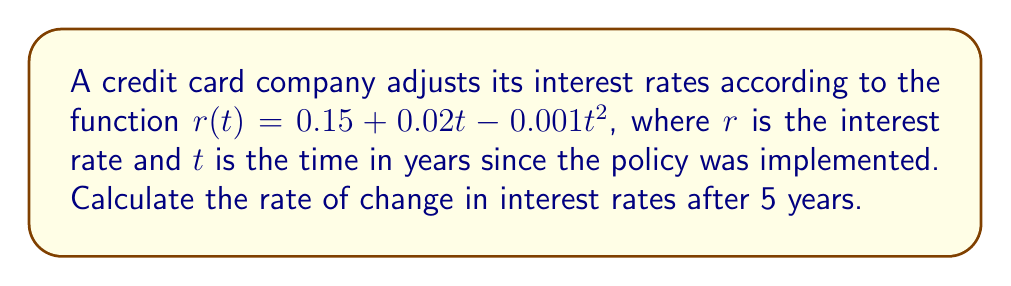Help me with this question. To find the rate of change in interest rates, we need to calculate the derivative of the given function and evaluate it at $t = 5$.

1. The given function is: $r(t) = 0.15 + 0.02t - 0.001t^2$

2. To find the derivative, we apply the power rule and constant rule:
   $$\frac{dr}{dt} = 0 + 0.02 - 0.001(2t) = 0.02 - 0.002t$$

3. Now we evaluate the derivative at $t = 5$:
   $$\frac{dr}{dt}\bigg|_{t=5} = 0.02 - 0.002(5) = 0.02 - 0.01 = 0.01$$

4. Convert the decimal to a percentage:
   $0.01 = 1\%$

Therefore, after 5 years, the interest rate is changing at a rate of 1% per year.
Answer: 1% per year 